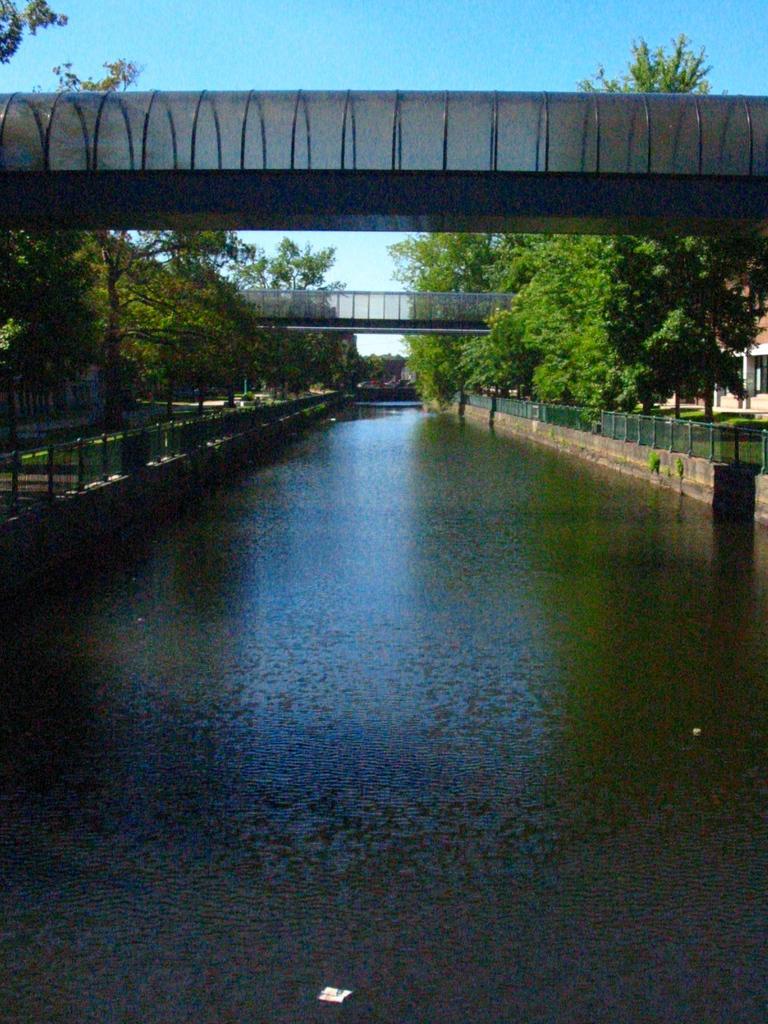How would you summarize this image in a sentence or two? There is water surface in the foreground area of the image, there are trees, it seems like a bridge, boundaries, house and the sky in the background. 